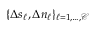<formula> <loc_0><loc_0><loc_500><loc_500>\{ \Delta s _ { \ell } , \Delta n _ { \ell } \} _ { \ell = 1 , \dots , \mathcal { C } }</formula> 